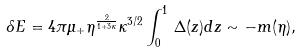Convert formula to latex. <formula><loc_0><loc_0><loc_500><loc_500>\delta E = 4 \pi \mu _ { + } \eta ^ { { \frac { 2 } { 1 + 3 \kappa } } } \kappa ^ { 3 / 2 } \int _ { 0 } ^ { 1 } \, \Delta ( z ) d z \sim - m ( \eta ) ,</formula> 